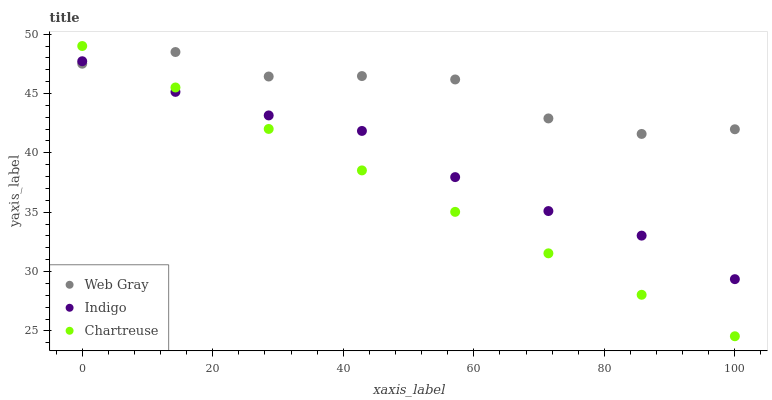Does Chartreuse have the minimum area under the curve?
Answer yes or no. Yes. Does Web Gray have the maximum area under the curve?
Answer yes or no. Yes. Does Indigo have the minimum area under the curve?
Answer yes or no. No. Does Indigo have the maximum area under the curve?
Answer yes or no. No. Is Chartreuse the smoothest?
Answer yes or no. Yes. Is Web Gray the roughest?
Answer yes or no. Yes. Is Indigo the smoothest?
Answer yes or no. No. Is Indigo the roughest?
Answer yes or no. No. Does Chartreuse have the lowest value?
Answer yes or no. Yes. Does Indigo have the lowest value?
Answer yes or no. No. Does Chartreuse have the highest value?
Answer yes or no. Yes. Does Web Gray have the highest value?
Answer yes or no. No. Does Indigo intersect Web Gray?
Answer yes or no. Yes. Is Indigo less than Web Gray?
Answer yes or no. No. Is Indigo greater than Web Gray?
Answer yes or no. No. 